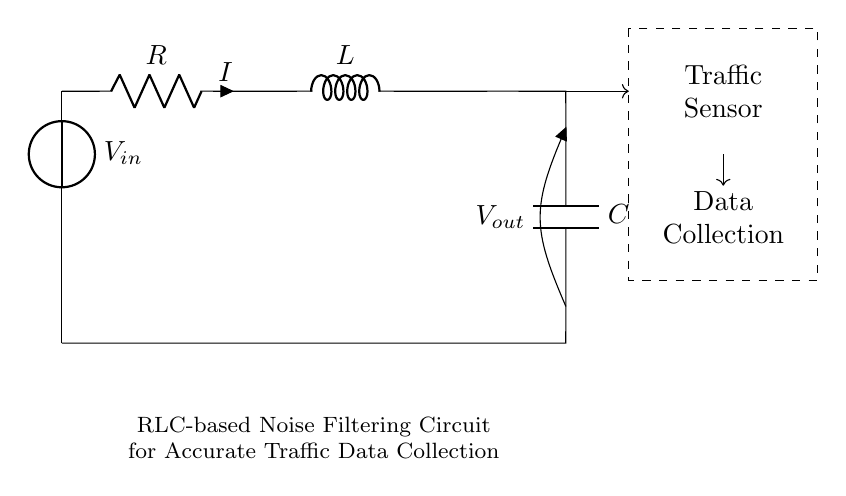What is the type of this circuit? The circuit is an RLC filter, which includes a resistor, inductor, and capacitor arranged to filter signals.
Answer: RLC filter What components are present in the circuit? The circuit contains three components: a resistor, an inductor, and a capacitor. These are clearly labeled in the diagram.
Answer: Resistor, inductor, capacitor What is the role of the capacitor in the circuit? The capacitor works to smooth out voltage fluctuations by storing and releasing energy, which helps in noise filtering from the traffic sensor data.
Answer: Noise filtering What is the current flowing through the circuit labeled as? The current through the resistor is labeled as “I,” which signifies the flow of electrical charge.
Answer: I How does the arrangement of components affect signal filtering? The arrangement of the resistor, inductor, and capacitor creates a specific frequency response, allowing certain frequencies to pass while attenuating others, thus enhancing the desired signals.
Answer: Frequency response What is indicated by the dashed rectangle in the circuit? The dashed rectangle represents the traffic sensor, indicating where real-time data is collected for traffic monitoring and analysis.
Answer: Traffic sensor What type of voltage source is shown at the beginning of the circuit? The voltage source is labeled as "Vin," indicating it is where the input voltage is supplied to the circuit.
Answer: Vin 